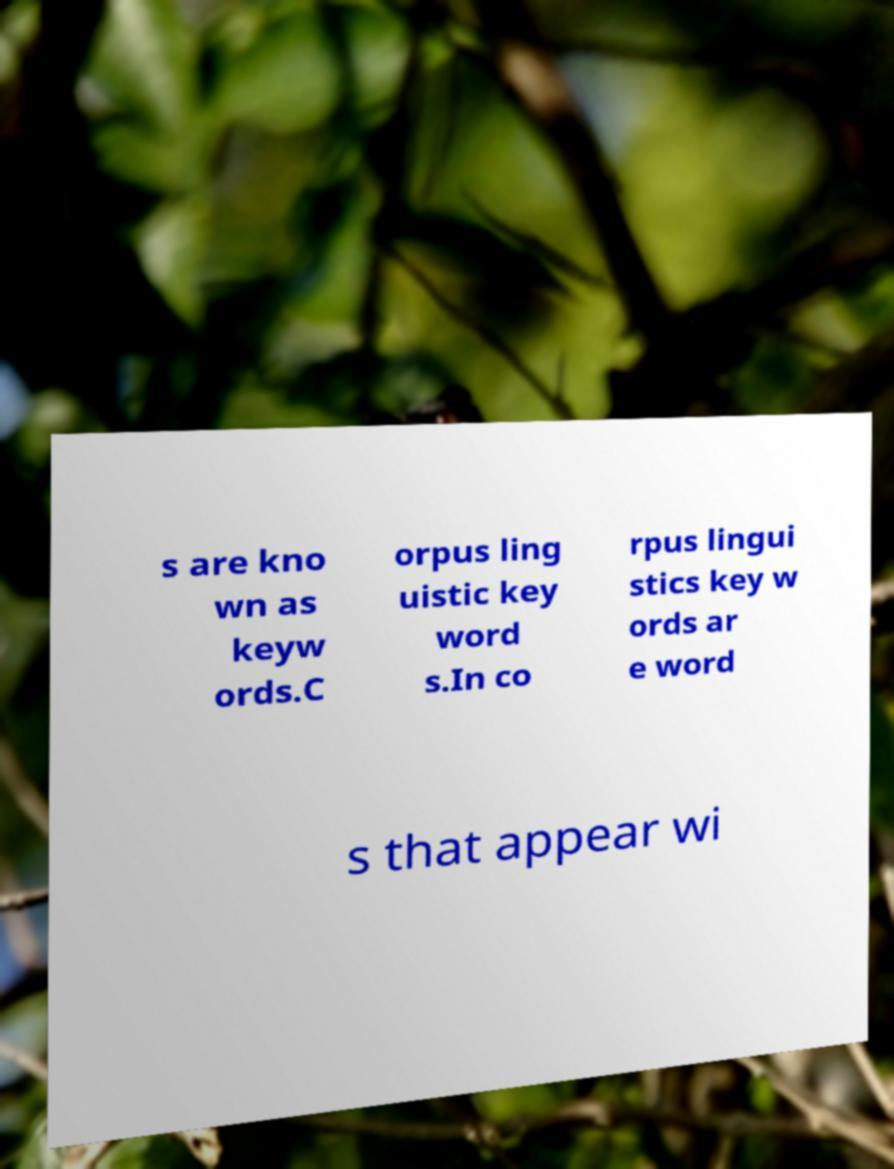Can you accurately transcribe the text from the provided image for me? s are kno wn as keyw ords.C orpus ling uistic key word s.In co rpus lingui stics key w ords ar e word s that appear wi 